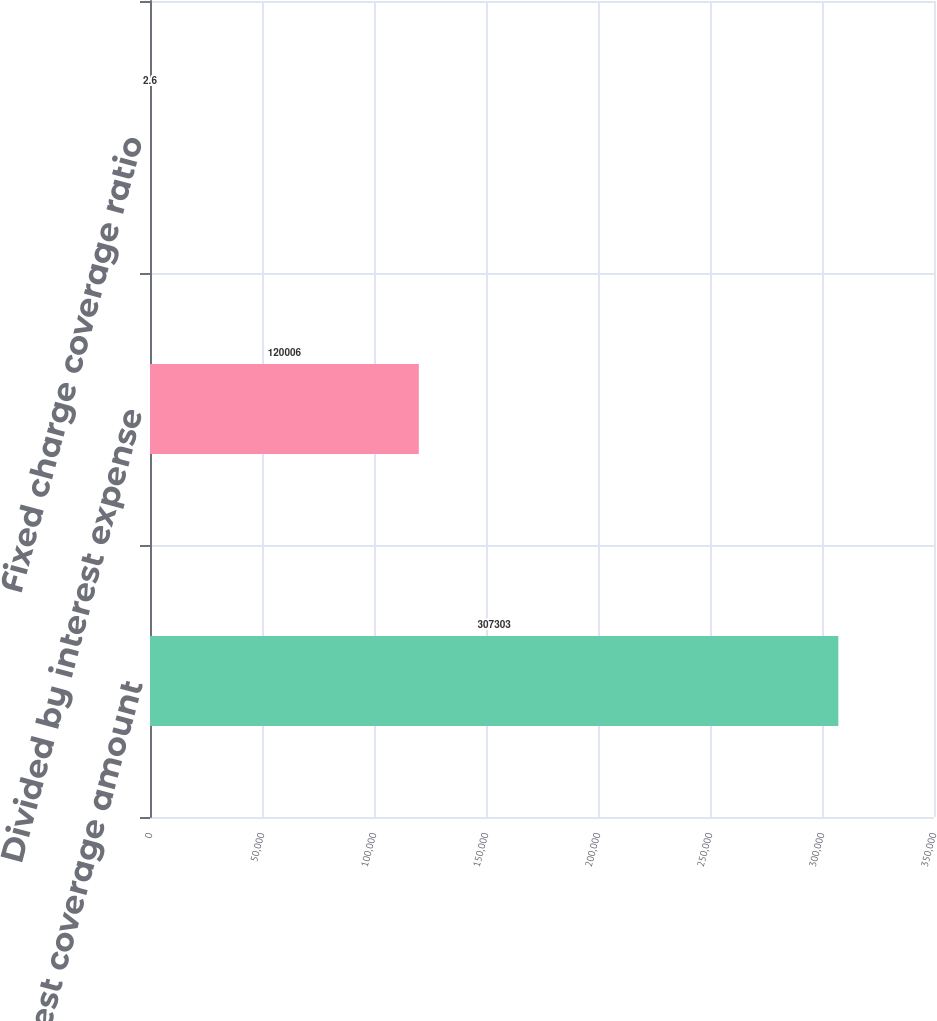Convert chart to OTSL. <chart><loc_0><loc_0><loc_500><loc_500><bar_chart><fcel>Interest coverage amount<fcel>Divided by interest expense<fcel>Fixed charge coverage ratio<nl><fcel>307303<fcel>120006<fcel>2.6<nl></chart> 